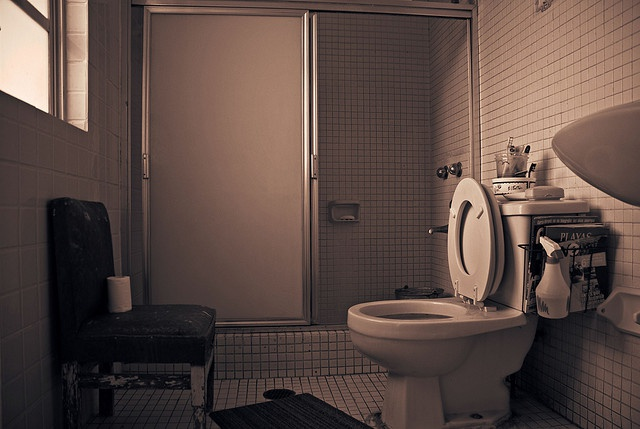Describe the objects in this image and their specific colors. I can see toilet in tan, black, and brown tones, chair in tan and black tones, sink in tan, brown, gray, maroon, and black tones, cup in tan, brown, gray, black, and maroon tones, and toothbrush in tan and gray tones in this image. 